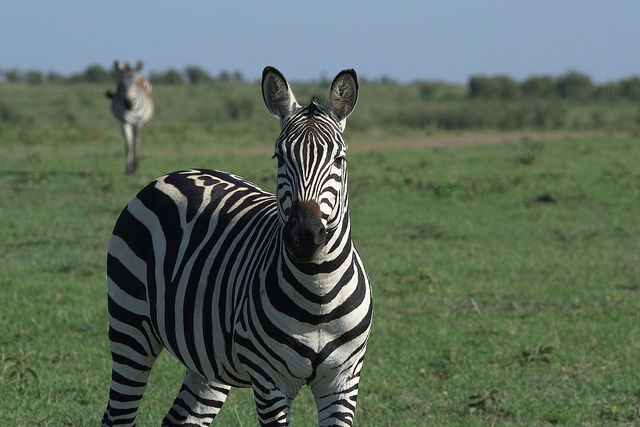Describe the objects in this image and their specific colors. I can see zebra in darkgray, black, gray, purple, and ivory tones and zebra in darkgray, gray, and black tones in this image. 